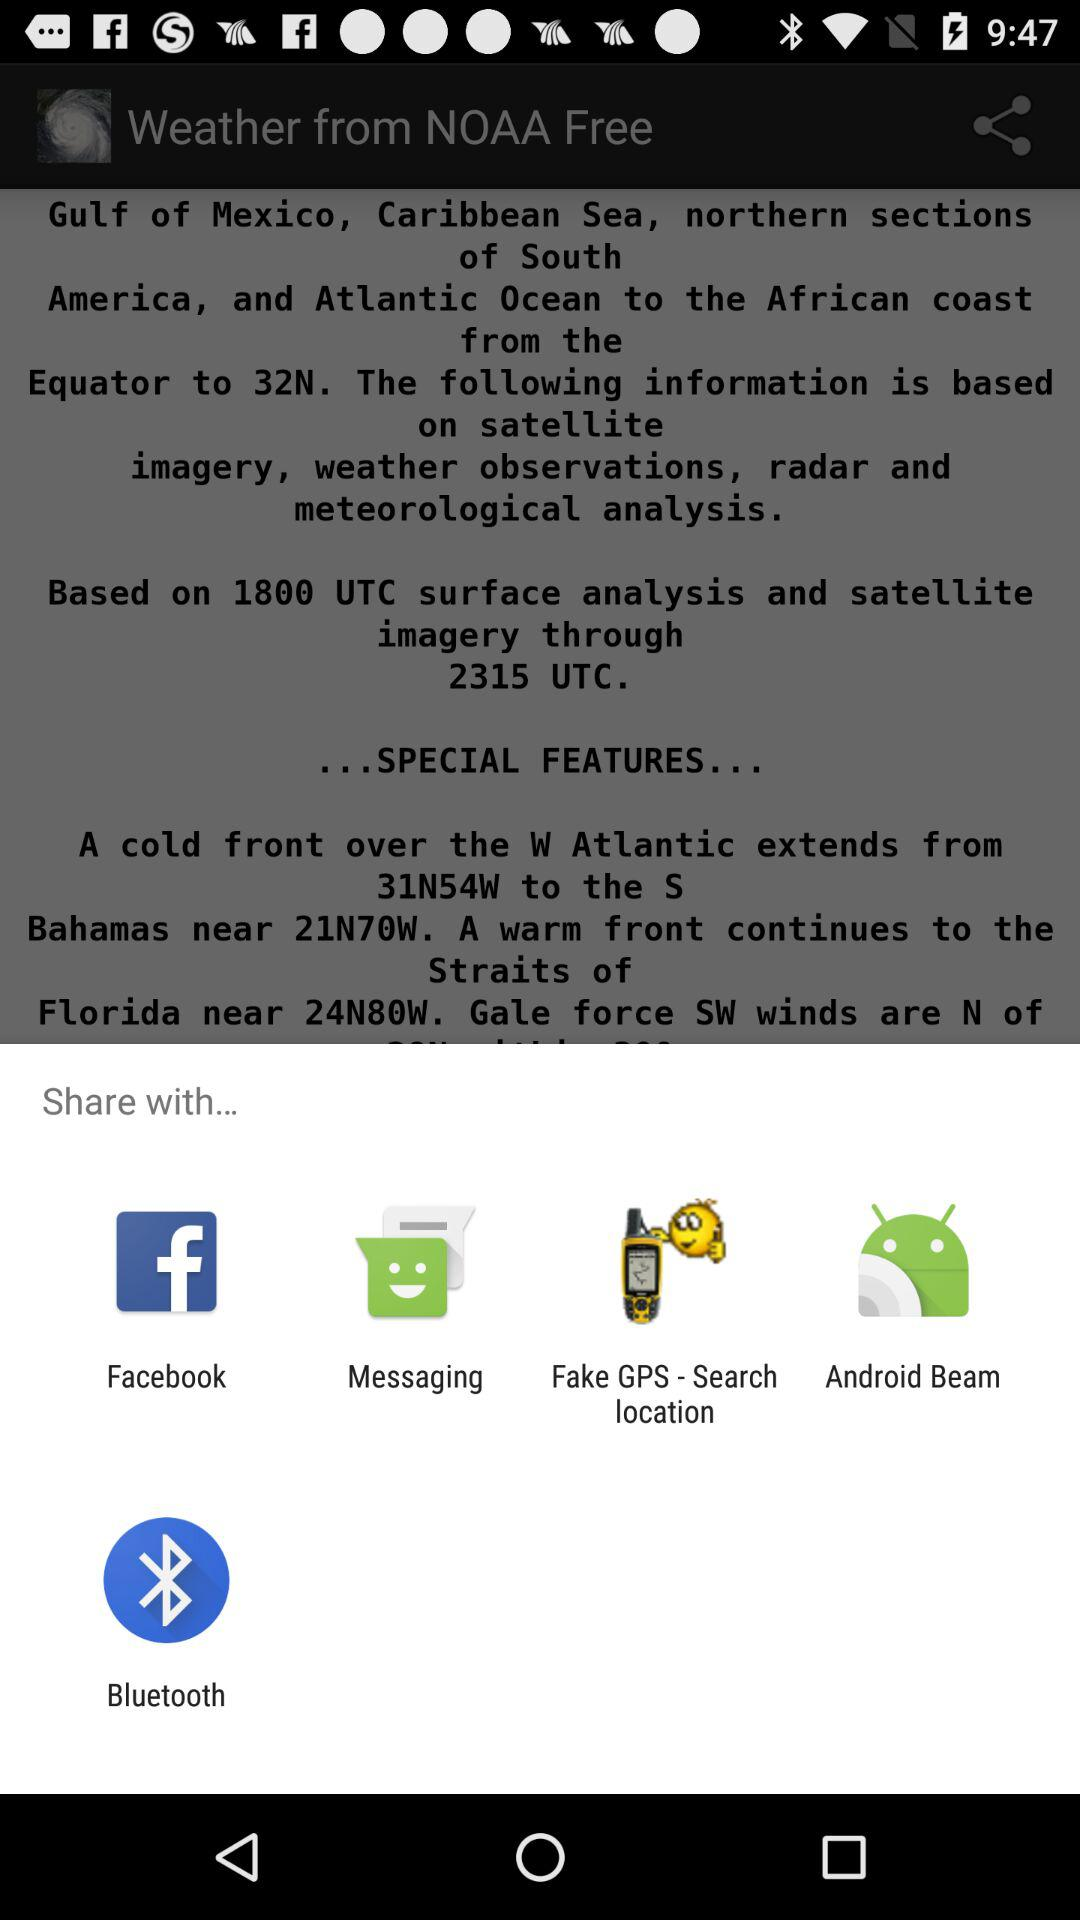What are the options for sharing the content? The options for sharing the content are "Facebook", "Messaging", "Fake GPS - Search location", "Android Beam" and "Bluetooth". 